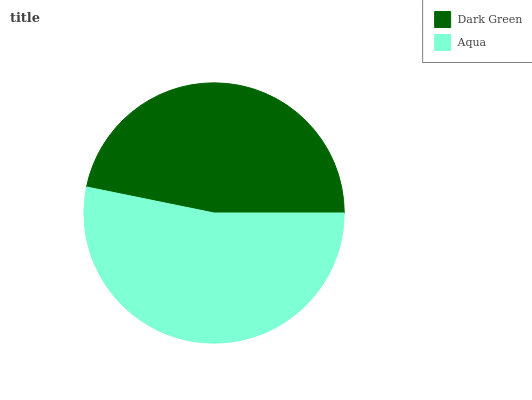Is Dark Green the minimum?
Answer yes or no. Yes. Is Aqua the maximum?
Answer yes or no. Yes. Is Aqua the minimum?
Answer yes or no. No. Is Aqua greater than Dark Green?
Answer yes or no. Yes. Is Dark Green less than Aqua?
Answer yes or no. Yes. Is Dark Green greater than Aqua?
Answer yes or no. No. Is Aqua less than Dark Green?
Answer yes or no. No. Is Aqua the high median?
Answer yes or no. Yes. Is Dark Green the low median?
Answer yes or no. Yes. Is Dark Green the high median?
Answer yes or no. No. Is Aqua the low median?
Answer yes or no. No. 